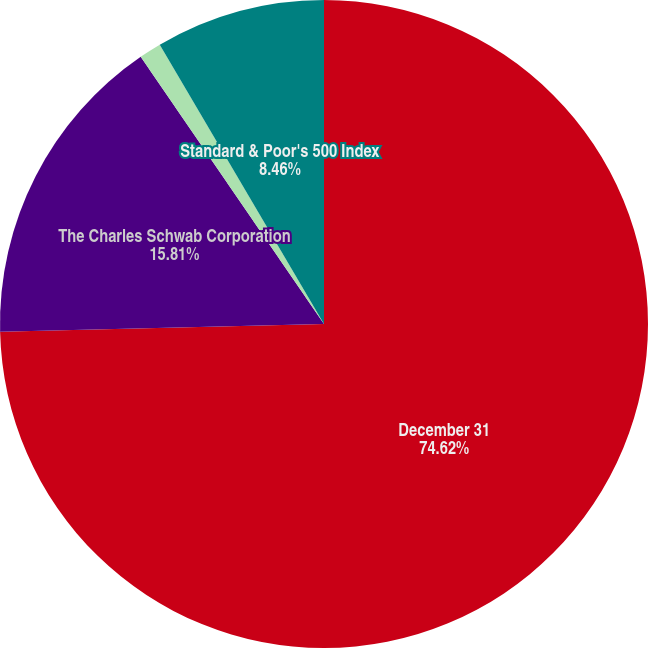<chart> <loc_0><loc_0><loc_500><loc_500><pie_chart><fcel>December 31<fcel>The Charles Schwab Corporation<fcel>Dow Jones US Investment<fcel>Standard & Poor's 500 Index<nl><fcel>74.61%<fcel>15.81%<fcel>1.11%<fcel>8.46%<nl></chart> 